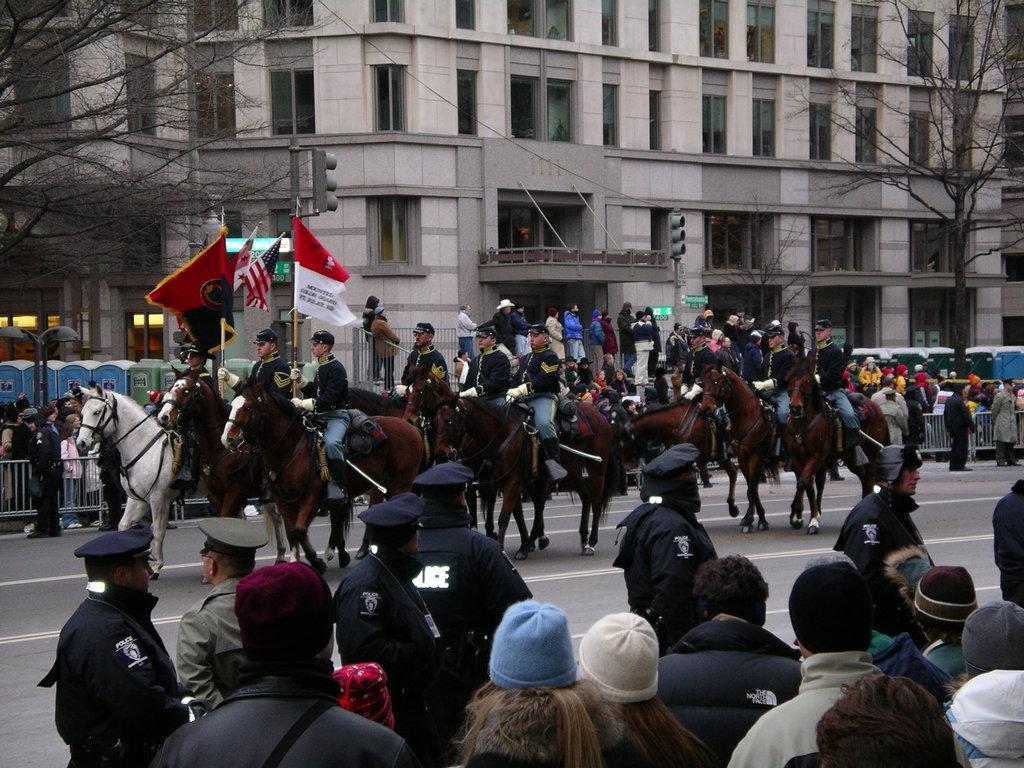Describe this image in one or two sentences. At the bottom of the image few people are standing. In front of them few people are riding horses and holding flags. Behind them few people are standing and there is fencing. Behind the fencing few people are standing and watching. At the top of the image there are some trees, poles and building. 